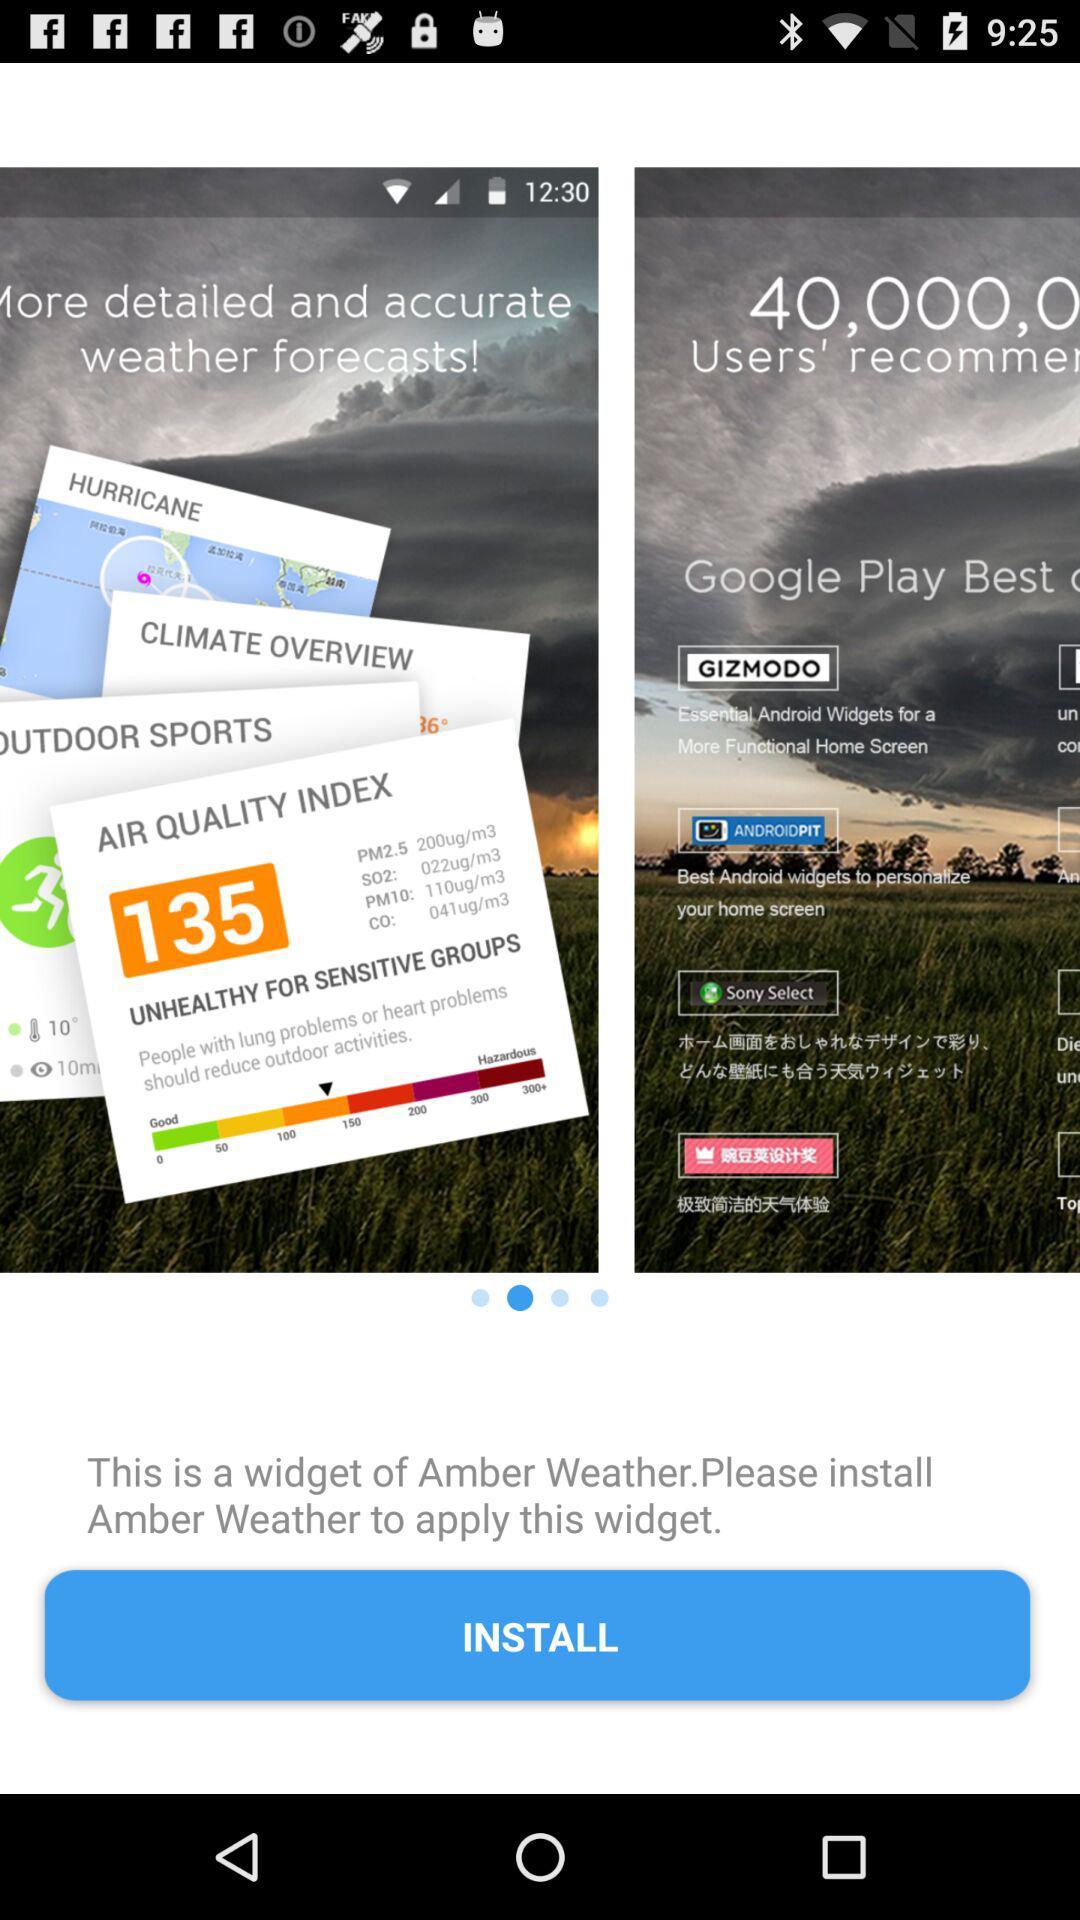What is the name of the application? The name of the application is "Amber Weather". 